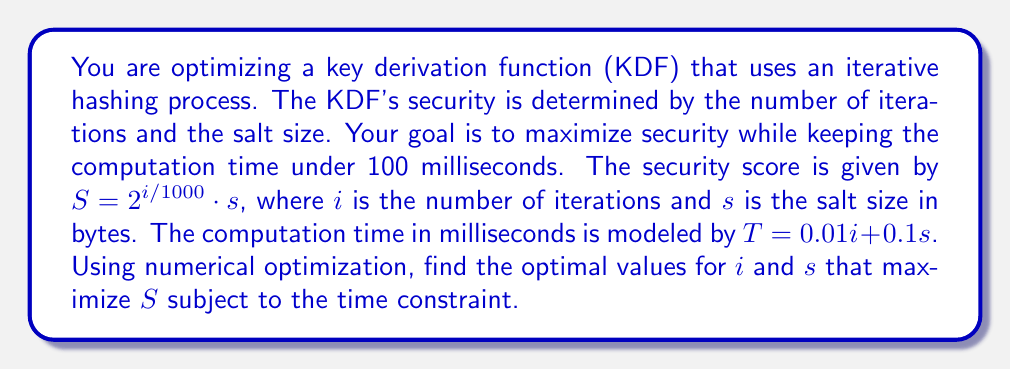Can you answer this question? To solve this optimization problem, we'll use the method of Lagrange multipliers:

1) Define the objective function and constraint:
   Maximize: $S = 2^{i/1000} \cdot s$
   Subject to: $T = 0.01i + 0.1s \leq 100$

2) Form the Lagrangian function:
   $L(i, s, \lambda) = 2^{i/1000} \cdot s + \lambda(100 - 0.01i - 0.1s)$

3) Calculate partial derivatives and set them to zero:
   $\frac{\partial L}{\partial i} = \frac{\ln 2}{1000} \cdot 2^{i/1000} \cdot s - 0.01\lambda = 0$
   $\frac{\partial L}{\partial s} = 2^{i/1000} - 0.1\lambda = 0$
   $\frac{\partial L}{\partial \lambda} = 100 - 0.01i - 0.1s = 0$

4) From the second equation:
   $\lambda = 10 \cdot 2^{i/1000}$

5) Substitute this into the first equation:
   $\frac{\ln 2}{1000} \cdot s = 0.1$
   $s = \frac{100}{\ln 2} \approx 144.27$

6) From the constraint equation:
   $100 = 0.01i + 0.1s$
   $100 = 0.01i + 0.1(144.27)$
   $i = 8573$

7) Round to nearest integers:
   $i = 8573$, $s = 144$ bytes

8) Verify the constraint:
   $T = 0.01(8573) + 0.1(144) = 99.97$ ms < 100 ms
Answer: $i = 8573$ iterations, $s = 144$ bytes 